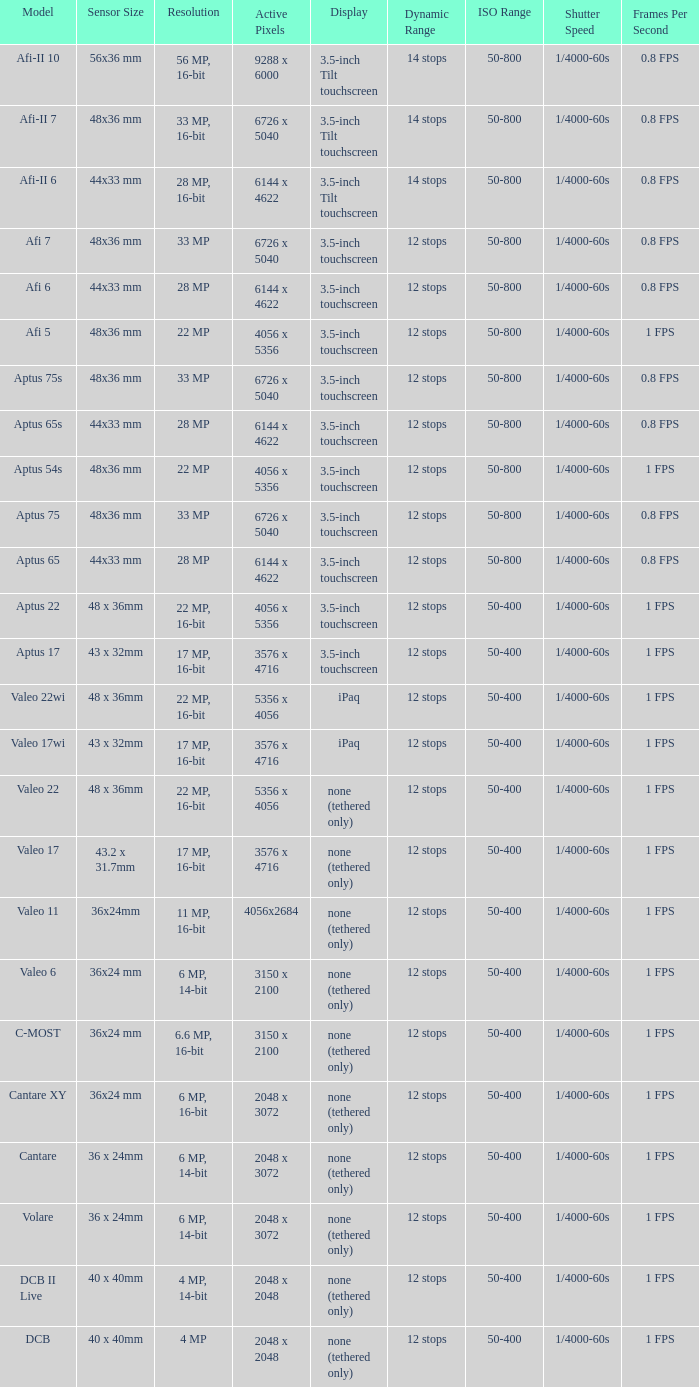What are the active pixels of the cantare model? 2048 x 3072. 